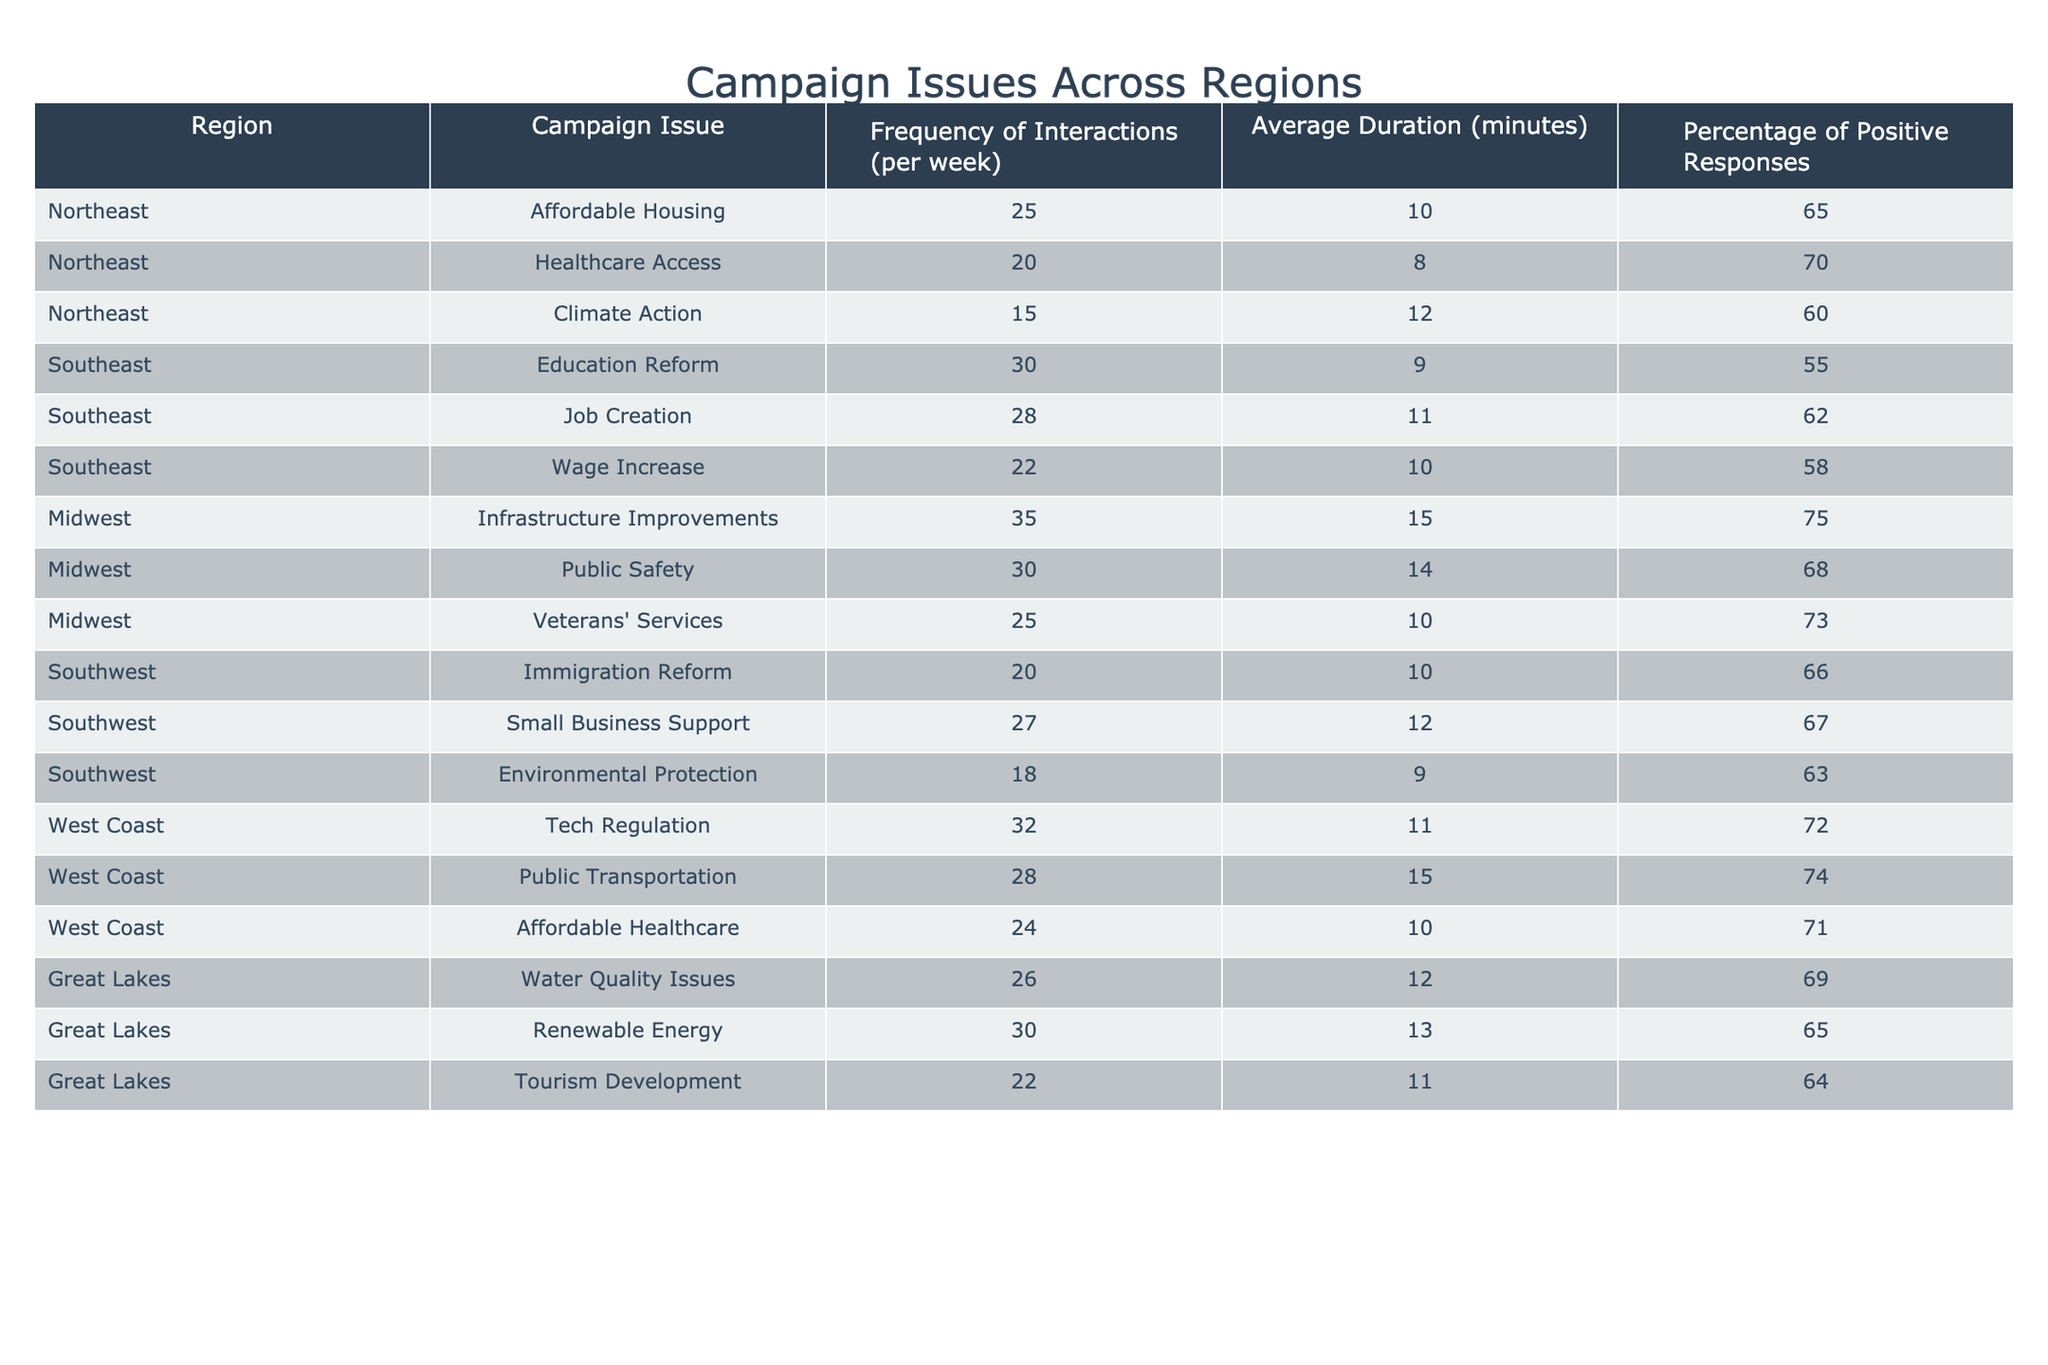What region has the highest frequency of interactions for Infrastructure Improvements? Looking at the table, I see that the Midwest has the highest frequency of interactions for Infrastructure Improvements, with a value of 35 interactions per week.
Answer: Midwest Which campaign issue has the lowest percentage of positive responses in the Southeast? In the Southeast region, the campaign issue with the lowest percentage of positive responses is Education Reform, with a percentage of 55%.
Answer: Education Reform What is the average duration of interactions for Affordable Healthcare? The table provides 24 minutes as the average duration of interactions for Affordable Healthcare in the West Coast region.
Answer: 24 How does the frequency of interactions for Climate Action in the Northeast compare to Job Creation in the Southeast? In the Northeast, the frequency of interactions for Climate Action is 15, while in the Southeast, Job Creation has a frequency of 28. Therefore, Job Creation has more interactions compared to Climate Action by 13 interactions.
Answer: Job Creation has more interactions Which region has the highest percentage of positive responses for Veterans' Services? The Midwest has the highest percentage of positive responses for Veterans' Services at 73%.
Answer: Midwest What is the total frequency of interactions for campaign issues in the Great Lakes region? The table shows the frequencies for the Great Lakes region as 26 (Water Quality Issues) + 30 (Renewable Energy) + 22 (Tourism Development), summing them gives 78 interactions in total.
Answer: 78 Is the average duration of interactions longer for Immigration Reform than for Environmental Protection? The average duration for Immigration Reform is 10 minutes and for Environmental Protection is 9 minutes. Thus, Immigration Reform has a longer average duration of 1 minute.
Answer: Yes What campaign issue has the highest percentage of positive responses in the West Coast? The campaign issue with the highest percentage of positive responses in the West Coast is Public Transportation, with a percentage of 74%.
Answer: Public Transportation Which region overall has the most issues with a frequency of interactions greater than 25 per week? Evaluating the data, the Midwest has three issues with frequencies greater than 25 (Infrastructure Improvements, Public Safety, Veterans' Services), which is the highest compared to other regions.
Answer: Midwest How many total campaign issues are reported for the Southwest region? The Southwest region has three campaign issues listed: Immigration Reform, Small Business Support, and Environmental Protection, making a total of 3 issues.
Answer: 3 